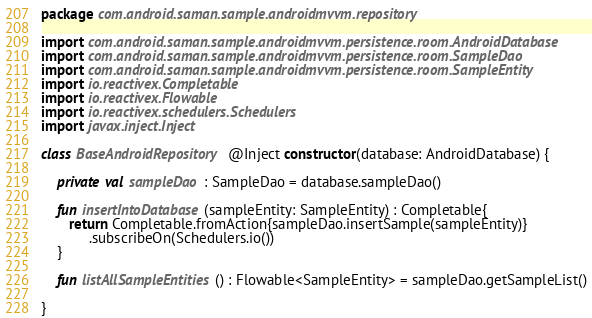<code> <loc_0><loc_0><loc_500><loc_500><_Kotlin_>package com.android.saman.sample.androidmvvm.repository

import com.android.saman.sample.androidmvvm.persistence.room.AndroidDatabase
import com.android.saman.sample.androidmvvm.persistence.room.SampleDao
import com.android.saman.sample.androidmvvm.persistence.room.SampleEntity
import io.reactivex.Completable
import io.reactivex.Flowable
import io.reactivex.schedulers.Schedulers
import javax.inject.Inject

class BaseAndroidRepository @Inject constructor(database: AndroidDatabase) {

    private val sampleDao : SampleDao = database.sampleDao()

    fun insertIntoDatabase(sampleEntity: SampleEntity) : Completable{
       return Completable.fromAction{sampleDao.insertSample(sampleEntity)}
            .subscribeOn(Schedulers.io())
    }

    fun listAllSampleEntities() : Flowable<SampleEntity> = sampleDao.getSampleList()

}</code> 